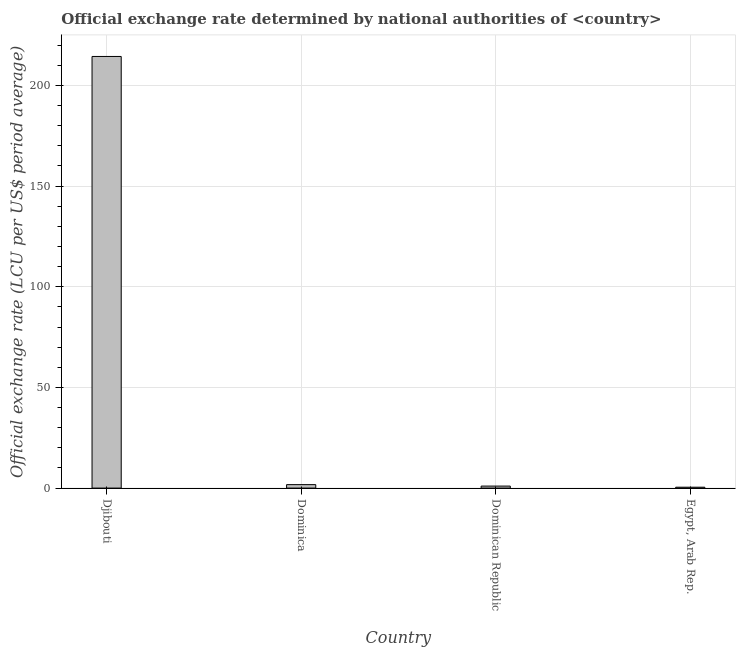Does the graph contain any zero values?
Your response must be concise. No. What is the title of the graph?
Your response must be concise. Official exchange rate determined by national authorities of <country>. What is the label or title of the X-axis?
Offer a terse response. Country. What is the label or title of the Y-axis?
Give a very brief answer. Official exchange rate (LCU per US$ period average). What is the official exchange rate in Djibouti?
Keep it short and to the point. 214.39. Across all countries, what is the maximum official exchange rate?
Ensure brevity in your answer.  214.39. Across all countries, what is the minimum official exchange rate?
Give a very brief answer. 0.43. In which country was the official exchange rate maximum?
Make the answer very short. Djibouti. In which country was the official exchange rate minimum?
Make the answer very short. Egypt, Arab Rep. What is the sum of the official exchange rate?
Your answer should be compact. 217.54. What is the difference between the official exchange rate in Djibouti and Dominican Republic?
Offer a terse response. 213.39. What is the average official exchange rate per country?
Offer a terse response. 54.38. What is the median official exchange rate?
Your response must be concise. 1.36. What is the ratio of the official exchange rate in Dominica to that in Egypt, Arab Rep.?
Offer a terse response. 3.94. Is the difference between the official exchange rate in Dominica and Egypt, Arab Rep. greater than the difference between any two countries?
Make the answer very short. No. What is the difference between the highest and the second highest official exchange rate?
Make the answer very short. 212.68. What is the difference between the highest and the lowest official exchange rate?
Your answer should be very brief. 213.96. How many bars are there?
Your answer should be very brief. 4. What is the Official exchange rate (LCU per US$ period average) of Djibouti?
Give a very brief answer. 214.39. What is the Official exchange rate (LCU per US$ period average) in Dominica?
Your response must be concise. 1.71. What is the Official exchange rate (LCU per US$ period average) of Egypt, Arab Rep.?
Provide a succinct answer. 0.43. What is the difference between the Official exchange rate (LCU per US$ period average) in Djibouti and Dominica?
Offer a very short reply. 212.68. What is the difference between the Official exchange rate (LCU per US$ period average) in Djibouti and Dominican Republic?
Provide a succinct answer. 213.39. What is the difference between the Official exchange rate (LCU per US$ period average) in Djibouti and Egypt, Arab Rep.?
Make the answer very short. 213.96. What is the difference between the Official exchange rate (LCU per US$ period average) in Dominica and Dominican Republic?
Make the answer very short. 0.71. What is the difference between the Official exchange rate (LCU per US$ period average) in Dominica and Egypt, Arab Rep.?
Keep it short and to the point. 1.28. What is the difference between the Official exchange rate (LCU per US$ period average) in Dominican Republic and Egypt, Arab Rep.?
Your response must be concise. 0.57. What is the ratio of the Official exchange rate (LCU per US$ period average) in Djibouti to that in Dominica?
Provide a short and direct response. 125.06. What is the ratio of the Official exchange rate (LCU per US$ period average) in Djibouti to that in Dominican Republic?
Your response must be concise. 214.39. What is the ratio of the Official exchange rate (LCU per US$ period average) in Djibouti to that in Egypt, Arab Rep.?
Provide a short and direct response. 493.1. What is the ratio of the Official exchange rate (LCU per US$ period average) in Dominica to that in Dominican Republic?
Give a very brief answer. 1.71. What is the ratio of the Official exchange rate (LCU per US$ period average) in Dominica to that in Egypt, Arab Rep.?
Your answer should be compact. 3.94. What is the ratio of the Official exchange rate (LCU per US$ period average) in Dominican Republic to that in Egypt, Arab Rep.?
Provide a short and direct response. 2.3. 